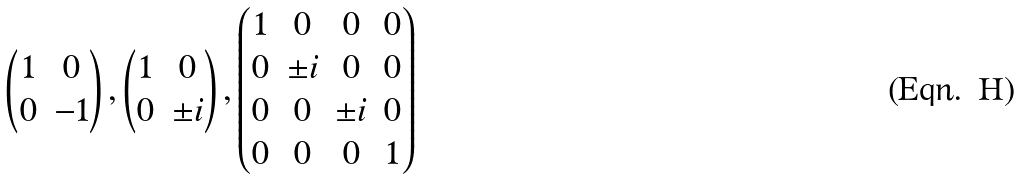<formula> <loc_0><loc_0><loc_500><loc_500>\begin{pmatrix} 1 & 0 \\ 0 & - 1 \end{pmatrix} , \begin{pmatrix} 1 & 0 \\ 0 & \pm i \end{pmatrix} , \begin{pmatrix} 1 & 0 & 0 & 0 \\ 0 & \pm i & 0 & 0 \\ 0 & 0 & \pm i & 0 \\ 0 & 0 & 0 & 1 \end{pmatrix}</formula> 